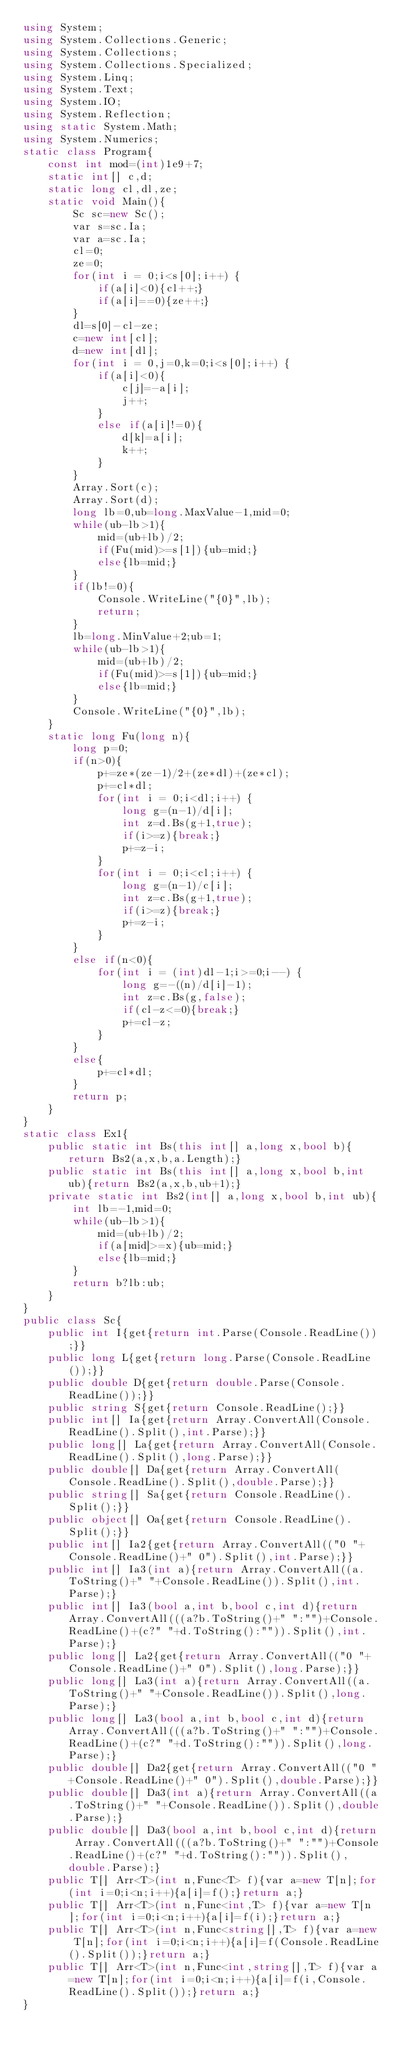<code> <loc_0><loc_0><loc_500><loc_500><_C#_>using System;
using System.Collections.Generic;
using System.Collections;
using System.Collections.Specialized;
using System.Linq;
using System.Text;
using System.IO;
using System.Reflection;
using static System.Math;
using System.Numerics;
static class Program{
	const int mod=(int)1e9+7;
	static int[] c,d;
	static long cl,dl,ze;
	static void Main(){
		Sc sc=new Sc();
		var s=sc.Ia;
		var a=sc.Ia;
		cl=0;
		ze=0;
		for(int i = 0;i<s[0];i++) {
			if(a[i]<0){cl++;}
			if(a[i]==0){ze++;}
		}
		dl=s[0]-cl-ze;
		c=new int[cl];
		d=new int[dl];
		for(int i = 0,j=0,k=0;i<s[0];i++) {
			if(a[i]<0){
				c[j]=-a[i];
				j++;
			}
			else if(a[i]!=0){
				d[k]=a[i];
				k++;
			}
		}
		Array.Sort(c);
		Array.Sort(d);
		long lb=0,ub=long.MaxValue-1,mid=0;
		while(ub-lb>1){
			mid=(ub+lb)/2;
			if(Fu(mid)>=s[1]){ub=mid;}
			else{lb=mid;}
		}
		if(lb!=0){
			Console.WriteLine("{0}",lb);
			return;
		}
		lb=long.MinValue+2;ub=1;
		while(ub-lb>1){
			mid=(ub+lb)/2;
			if(Fu(mid)>=s[1]){ub=mid;}
			else{lb=mid;}
		}
		Console.WriteLine("{0}",lb);
	}
	static long Fu(long n){
		long p=0;
		if(n>0){
			p+=ze*(ze-1)/2+(ze*dl)+(ze*cl);
			p+=cl*dl;
			for(int i = 0;i<dl;i++) {
				long g=(n-1)/d[i];
				int z=d.Bs(g+1,true);
				if(i>=z){break;}
				p+=z-i;
			}
			for(int i = 0;i<cl;i++) {
				long g=(n-1)/c[i];
				int z=c.Bs(g+1,true);
				if(i>=z){break;}
				p+=z-i;
			}
		}
		else if(n<0){
			for(int i = (int)dl-1;i>=0;i--) {
				long g=-((n)/d[i]-1);
				int z=c.Bs(g,false);
				if(cl-z<=0){break;}
				p+=cl-z;
			}
		}
		else{
			p+=cl*dl;
		}
		return p;
	}
}
static class Ex1{
	public static int Bs(this int[] a,long x,bool b){return Bs2(a,x,b,a.Length);}
	public static int Bs(this int[] a,long x,bool b,int ub){return Bs2(a,x,b,ub+1);}
	private static int Bs2(int[] a,long x,bool b,int ub){
		int lb=-1,mid=0;
		while(ub-lb>1){
			mid=(ub+lb)/2;
			if(a[mid]>=x){ub=mid;}
			else{lb=mid;}
		}
		return b?lb:ub;
	}
}
public class Sc{
	public int I{get{return int.Parse(Console.ReadLine());}}
	public long L{get{return long.Parse(Console.ReadLine());}}
	public double D{get{return double.Parse(Console.ReadLine());}}
	public string S{get{return Console.ReadLine();}}
	public int[] Ia{get{return Array.ConvertAll(Console.ReadLine().Split(),int.Parse);}}
	public long[] La{get{return Array.ConvertAll(Console.ReadLine().Split(),long.Parse);}}
	public double[] Da{get{return Array.ConvertAll(Console.ReadLine().Split(),double.Parse);}}
	public string[] Sa{get{return Console.ReadLine().Split();}}
	public object[] Oa{get{return Console.ReadLine().Split();}}
	public int[] Ia2{get{return Array.ConvertAll(("0 "+Console.ReadLine()+" 0").Split(),int.Parse);}}
	public int[] Ia3(int a){return Array.ConvertAll((a.ToString()+" "+Console.ReadLine()).Split(),int.Parse);}
	public int[] Ia3(bool a,int b,bool c,int d){return Array.ConvertAll(((a?b.ToString()+" ":"")+Console.ReadLine()+(c?" "+d.ToString():"")).Split(),int.Parse);}
	public long[] La2{get{return Array.ConvertAll(("0 "+Console.ReadLine()+" 0").Split(),long.Parse);}}
	public long[] La3(int a){return Array.ConvertAll((a.ToString()+" "+Console.ReadLine()).Split(),long.Parse);}
	public long[] La3(bool a,int b,bool c,int d){return Array.ConvertAll(((a?b.ToString()+" ":"")+Console.ReadLine()+(c?" "+d.ToString():"")).Split(),long.Parse);}
	public double[] Da2{get{return Array.ConvertAll(("0 "+Console.ReadLine()+" 0").Split(),double.Parse);}}
	public double[] Da3(int a){return Array.ConvertAll((a.ToString()+" "+Console.ReadLine()).Split(),double.Parse);}
	public double[] Da3(bool a,int b,bool c,int d){return Array.ConvertAll(((a?b.ToString()+" ":"")+Console.ReadLine()+(c?" "+d.ToString():"")).Split(),double.Parse);}
	public T[] Arr<T>(int n,Func<T> f){var a=new T[n];for(int i=0;i<n;i++){a[i]=f();}return a;}
	public T[] Arr<T>(int n,Func<int,T> f){var a=new T[n];for(int i=0;i<n;i++){a[i]=f(i);}return a;}
	public T[] Arr<T>(int n,Func<string[],T> f){var a=new T[n];for(int i=0;i<n;i++){a[i]=f(Console.ReadLine().Split());}return a;}
	public T[] Arr<T>(int n,Func<int,string[],T> f){var a=new T[n];for(int i=0;i<n;i++){a[i]=f(i,Console.ReadLine().Split());}return a;}
}</code> 